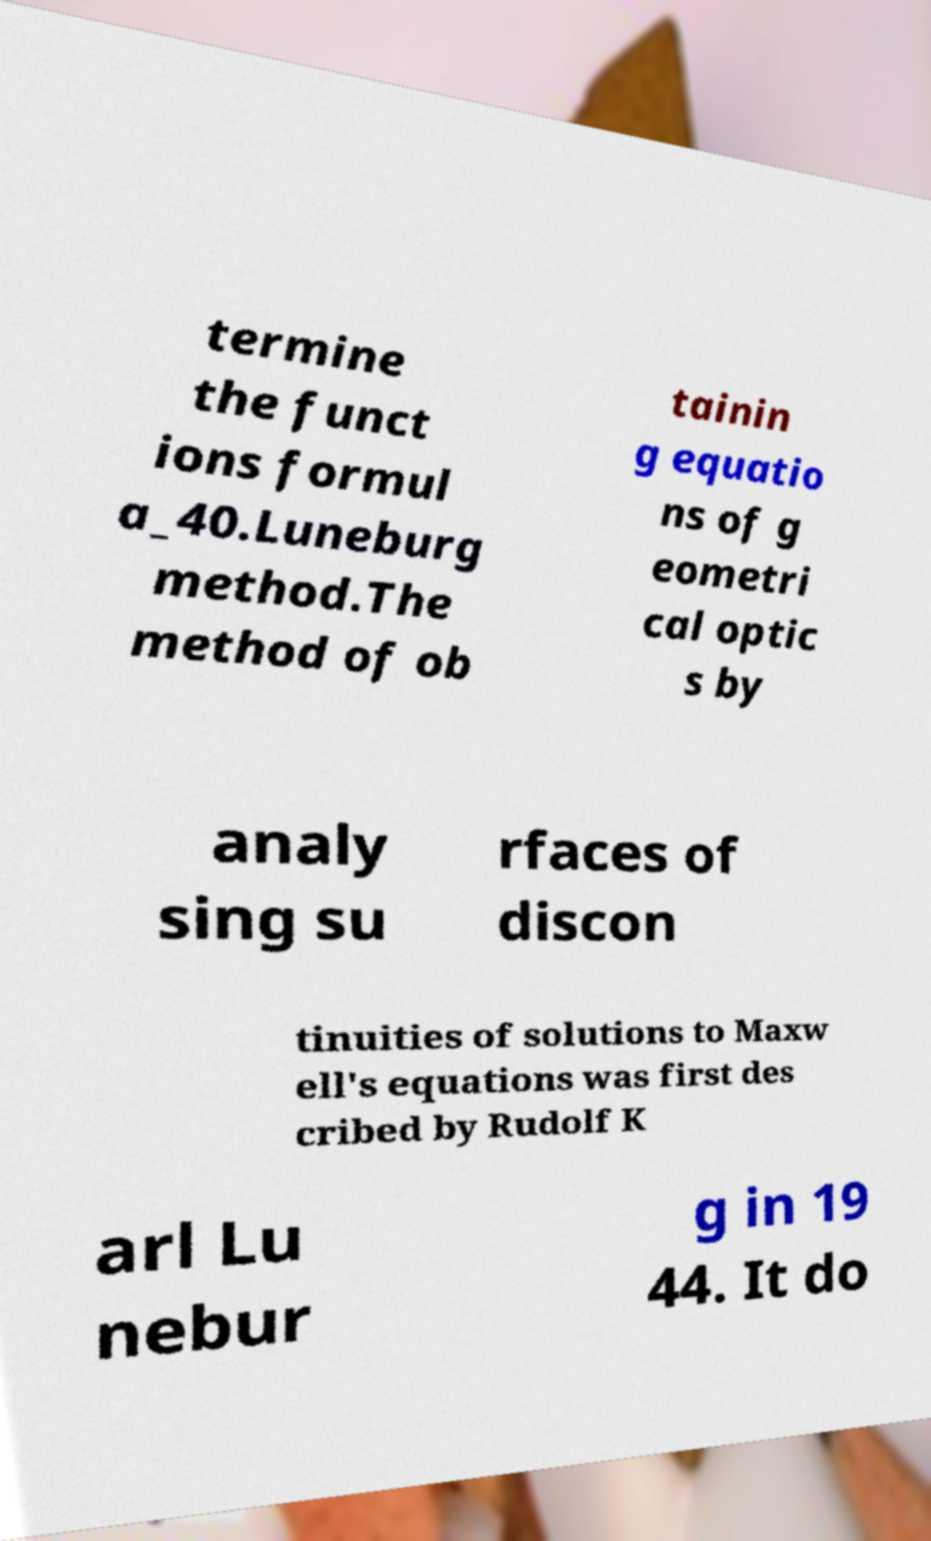For documentation purposes, I need the text within this image transcribed. Could you provide that? termine the funct ions formul a_40.Luneburg method.The method of ob tainin g equatio ns of g eometri cal optic s by analy sing su rfaces of discon tinuities of solutions to Maxw ell's equations was first des cribed by Rudolf K arl Lu nebur g in 19 44. It do 